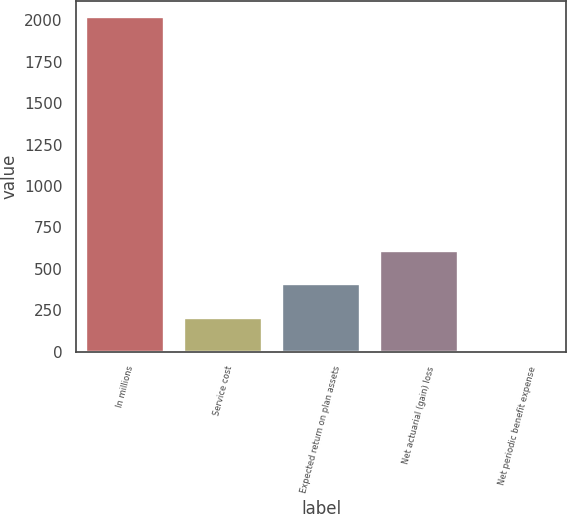<chart> <loc_0><loc_0><loc_500><loc_500><bar_chart><fcel>In millions<fcel>Service cost<fcel>Expected return on plan assets<fcel>Net actuarial (gain) loss<fcel>Net periodic benefit expense<nl><fcel>2016<fcel>205.02<fcel>406.24<fcel>607.46<fcel>3.8<nl></chart> 